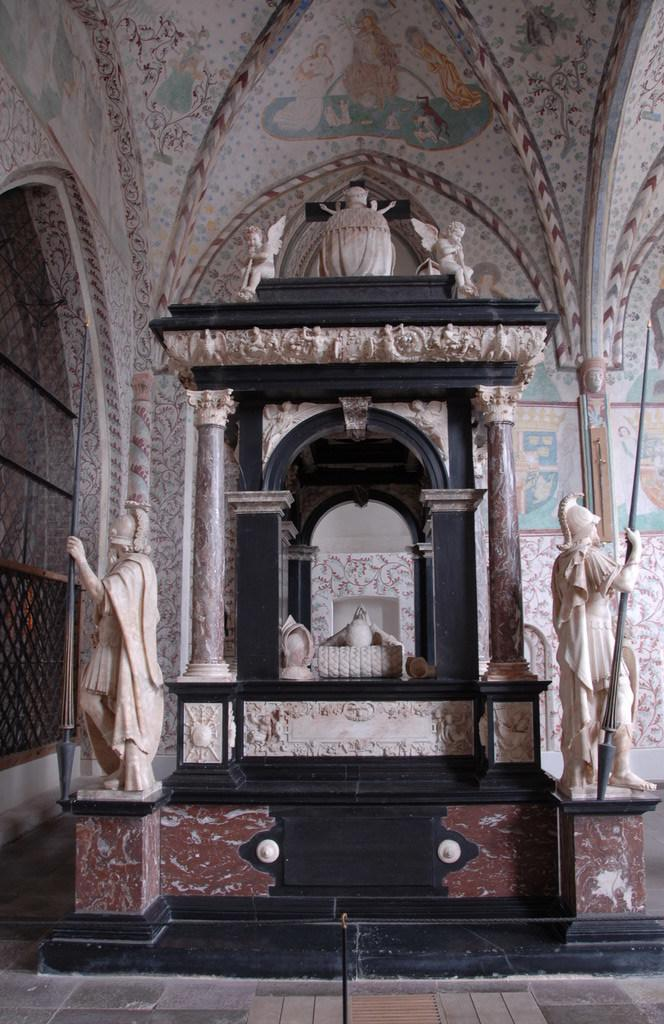What type of location is depicted in the image? The image shows an inside view of a building. Can you describe the statues in the image? There are two statues, one on the right side and one on the left side. What can be seen in the background of the image? There is a wall in the background of the image. What type of lamp is being used to cast a shadow on the statue on the right side? There is no lamp or shadow present in the image; it only shows the statues and the wall in the background. 